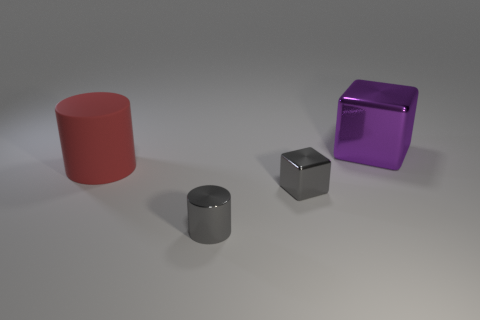What material is the thing that is the same size as the gray metallic cylinder?
Make the answer very short. Metal. What is the material of the cylinder that is on the right side of the big object in front of the cube behind the large red matte thing?
Your answer should be compact. Metal. Are there fewer big purple things that are behind the purple shiny block than metallic cylinders in front of the red cylinder?
Offer a very short reply. Yes. What is the color of the big cylinder?
Keep it short and to the point. Red. How many shiny objects have the same color as the small metallic cube?
Offer a very short reply. 1. There is a tiny cylinder; are there any big objects left of it?
Make the answer very short. Yes. Is the number of small things to the right of the gray block the same as the number of small gray metal blocks that are on the right side of the rubber thing?
Your response must be concise. No. Is the size of the cube that is in front of the large purple block the same as the gray shiny object in front of the gray cube?
Your answer should be very brief. Yes. There is a large red matte thing that is on the left side of the metal block to the right of the cube in front of the big shiny cube; what is its shape?
Ensure brevity in your answer.  Cylinder. Is there anything else that has the same material as the red object?
Offer a very short reply. No. 